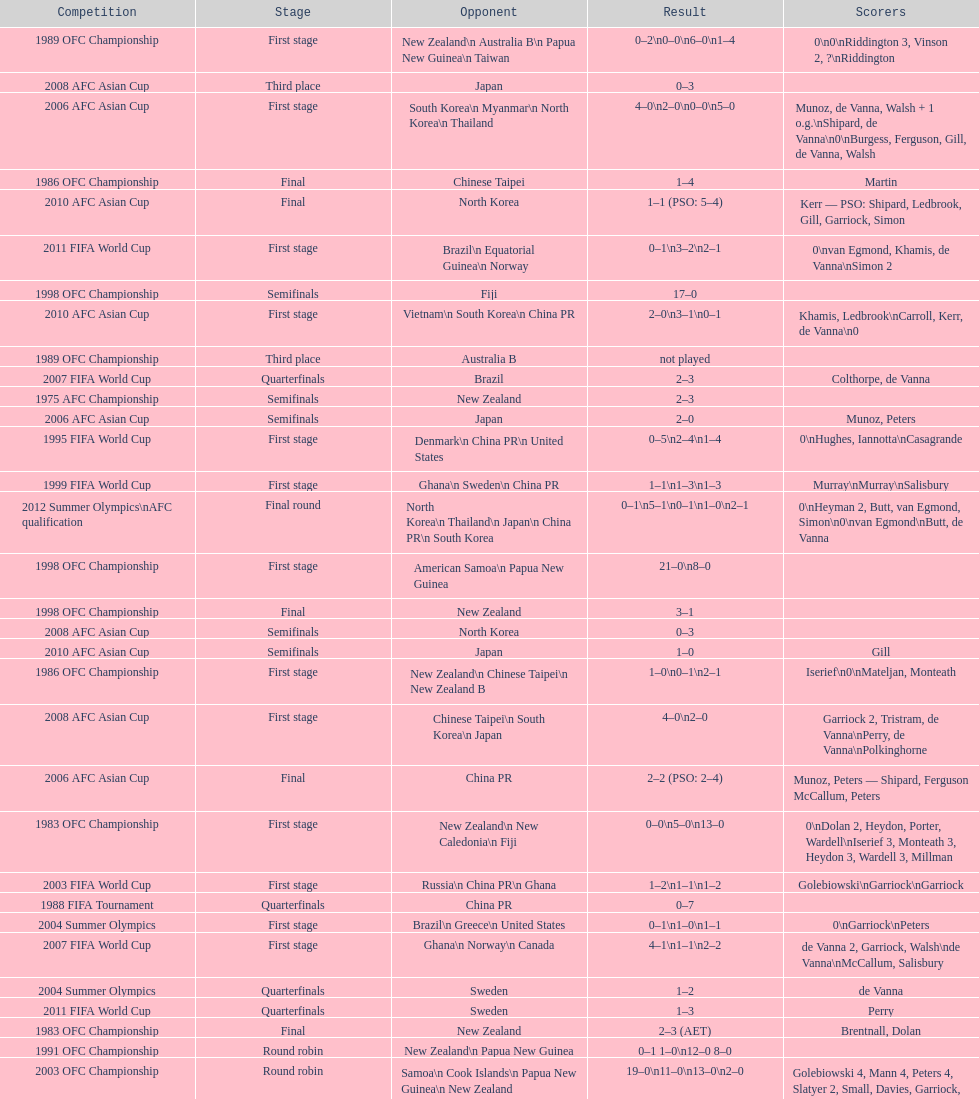What is the total number of competitions? 21. 